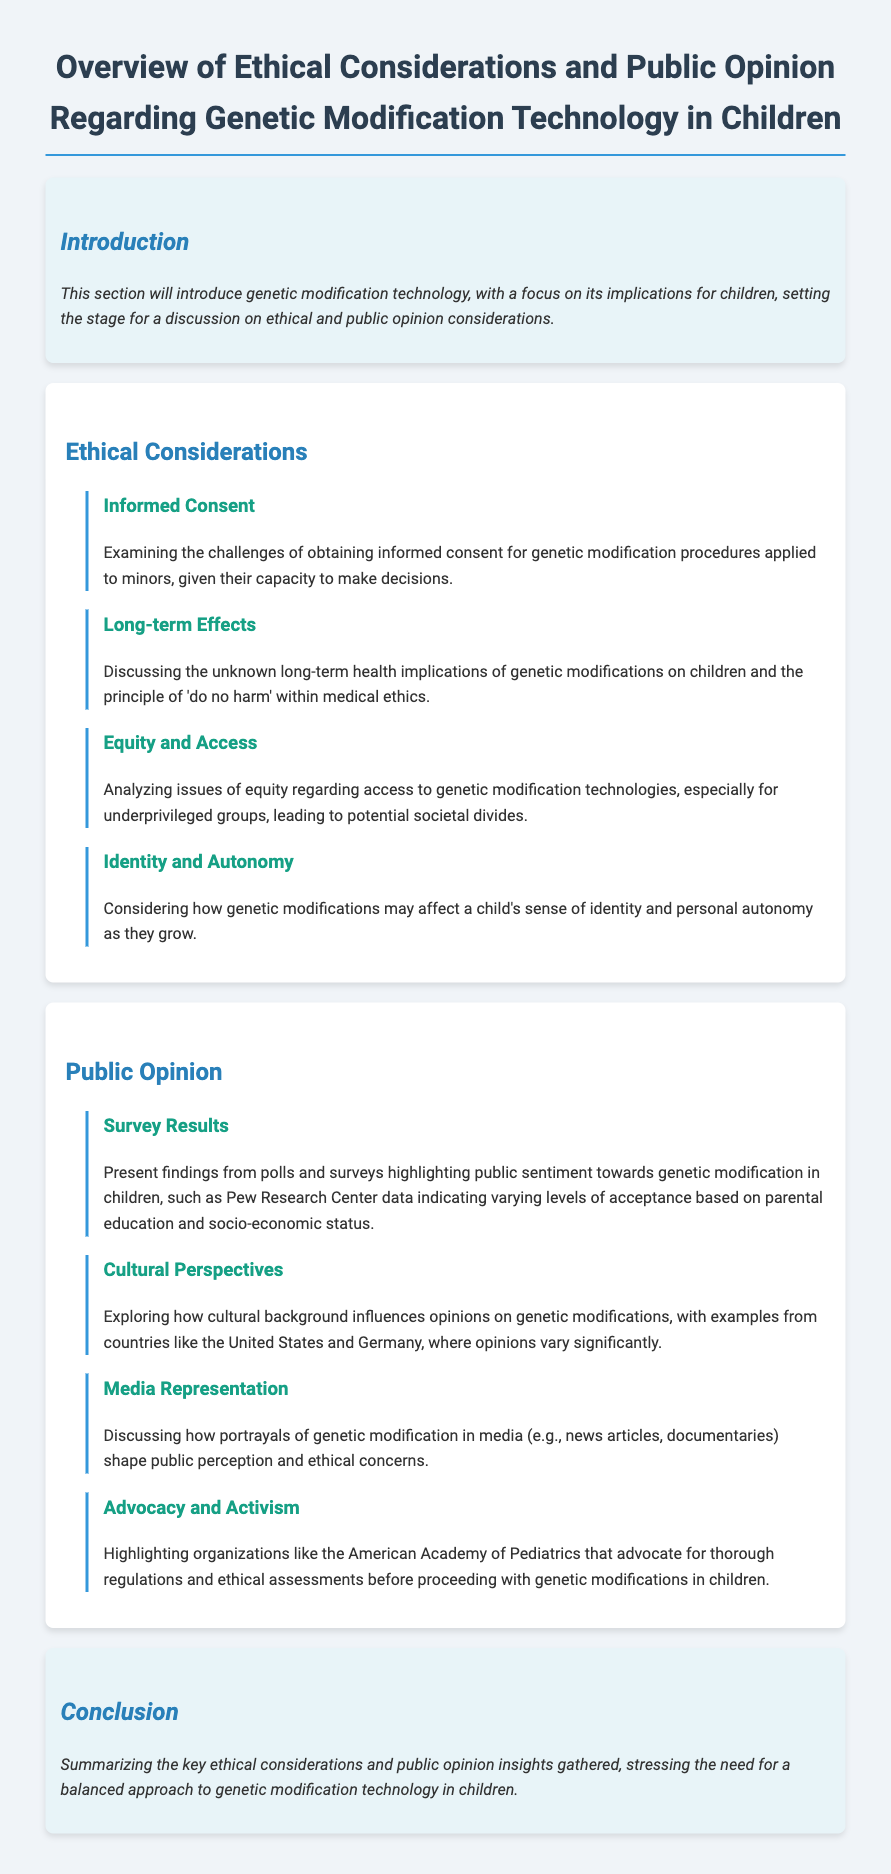What is the title of the document? The title summarizes the document's main focus on genetic modification technology in children.
Answer: Overview of Ethical Considerations and Public Opinion Regarding Genetic Modification Technology in Children Who discusses informed consent in the context of genetic modification? This topic is addressed within the Ethical Considerations section detailing challenges in obtaining consent for minors.
Answer: Ethical Considerations What principle is highlighted in the Long-term Effects subsection? The principle emphasizes the medical ethical guideline of ensuring no harm is done in treatment procedures.
Answer: Do no harm Which organization advocates for regulations before proceeding with genetic modifications? This information is found in the Advocacy and Activism subsection discussing ethical assessments needed.
Answer: American Academy of Pediatrics How does cultural background influence opinions on genetic modification? This relationship is explored in the Cultural Perspectives subsection indicating varying opinions across different countries.
Answer: Cultural background What is mentioned about media representation in public opinion? This topic is covered in the Media Representation subsection which explains how media shapes public perception.
Answer: Media representation What is the tone of the conclusion section? The conclusion provides a summarization of insights and emphasizes a need for a careful approach.
Answer: Balanced approach What type of survey data is highlighted in the document? The document mentions findings from polls and surveys which reflect varying levels of acceptance towards genetic modifications based on specific demographics.
Answer: Survey results 